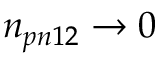<formula> <loc_0><loc_0><loc_500><loc_500>n _ { p n 1 2 } \rightarrow 0</formula> 